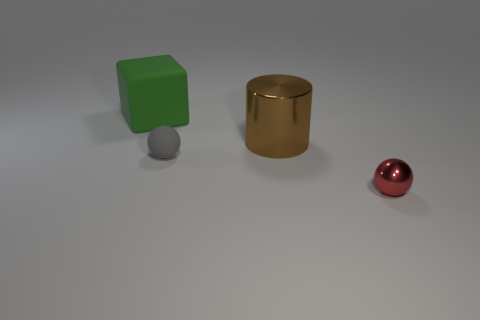Add 4 large green cylinders. How many objects exist? 8 Subtract all blocks. How many objects are left? 3 Add 3 matte balls. How many matte balls are left? 4 Add 2 big brown shiny objects. How many big brown shiny objects exist? 3 Subtract 0 purple balls. How many objects are left? 4 Subtract all large green rubber cubes. Subtract all metallic things. How many objects are left? 1 